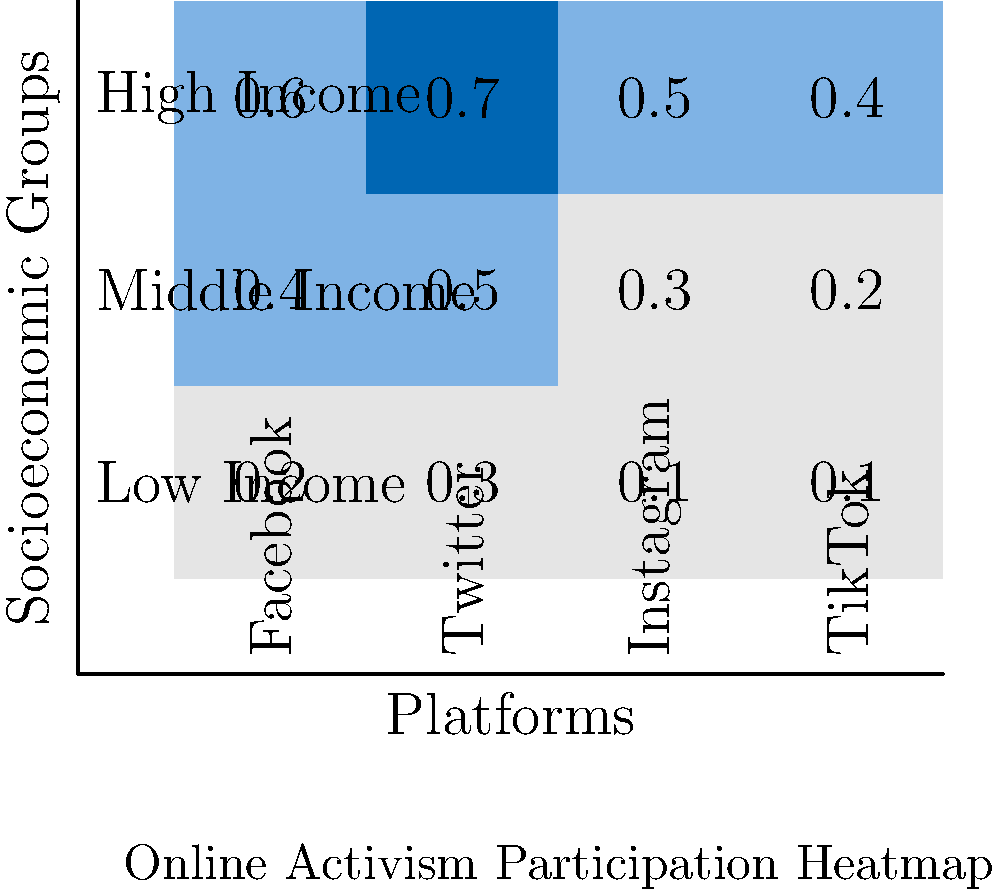Based on the heatmap illustrating online activism participation across different socioeconomic groups, which platform shows the highest level of engagement for all income groups, and how does this relate to Schradie's digital activism gap theory? To answer this question, we need to analyze the heatmap and relate it to Schradie's digital activism gap theory. Let's break it down step-by-step:

1. Examine the heatmap:
   - The rows represent socioeconomic groups: Low Income, Middle Income, and High Income.
   - The columns represent social media platforms: Facebook, Twitter, Instagram, and TikTok.
   - The values in each cell represent the participation rate (from 0 to 1).

2. Identify the platform with the highest engagement:
   - Facebook: 0.2 (Low), 0.4 (Middle), 0.6 (High)
   - Twitter: 0.3 (Low), 0.5 (Middle), 0.7 (High)
   - Instagram: 0.1 (Low), 0.3 (Middle), 0.5 (High)
   - TikTok: 0.1 (Low), 0.2 (Middle), 0.4 (High)

   Twitter has the highest values across all income groups.

3. Relate to Schradie's digital activism gap theory:
   - Schradie argues that there's a class-based digital activism gap, where higher socioeconomic status groups are more likely to engage in online activism.
   - The heatmap supports this theory, as participation rates increase from low to high income groups across all platforms.
   - Twitter, while having the highest engagement, still shows a clear gap between low (0.3) and high (0.7) income groups.

4. Consider the implications:
   - The data suggests that Twitter is the most popular platform for online activism across all groups.
   - However, the persistent gap in participation rates across income levels aligns with Schradie's theory about digital inequality in activism.
Answer: Twitter; confirms Schradie's digital activism gap theory 